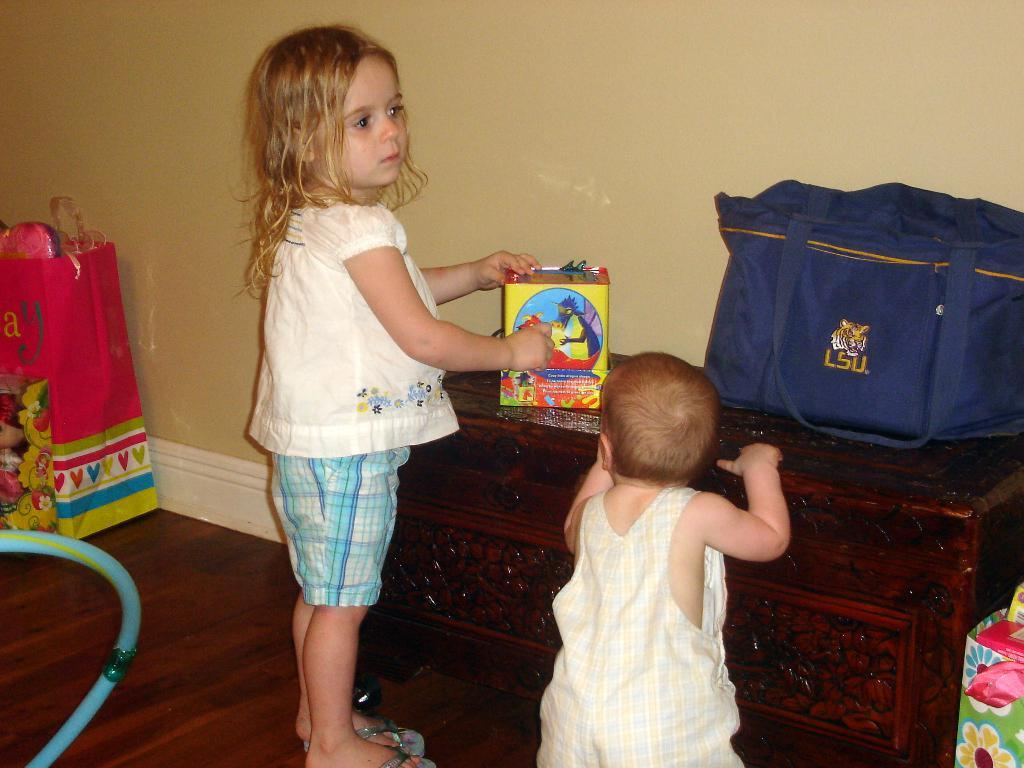How many people are present in the image? There are two people standing in the image. What is one person holding in the image? One person is holding a box. What can be seen on the table in the image? There is a blue bag on a table in the image. What color is the wall in the image? The wall in the image is cream-colored. What is on the floor in the image? There are objects on the floor in the image. Can you see any steam coming from the toes of the people in the image? There are no toes visible in the image, and therefore no steam can be seen coming from them. 